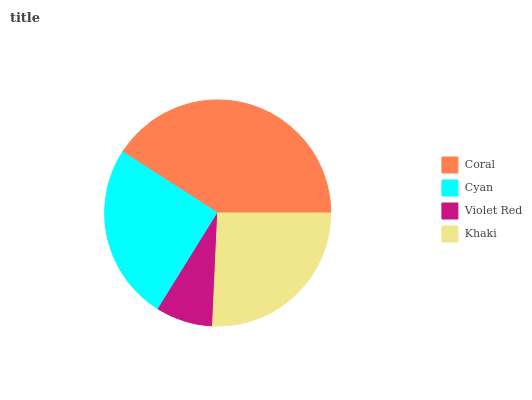Is Violet Red the minimum?
Answer yes or no. Yes. Is Coral the maximum?
Answer yes or no. Yes. Is Cyan the minimum?
Answer yes or no. No. Is Cyan the maximum?
Answer yes or no. No. Is Coral greater than Cyan?
Answer yes or no. Yes. Is Cyan less than Coral?
Answer yes or no. Yes. Is Cyan greater than Coral?
Answer yes or no. No. Is Coral less than Cyan?
Answer yes or no. No. Is Khaki the high median?
Answer yes or no. Yes. Is Cyan the low median?
Answer yes or no. Yes. Is Violet Red the high median?
Answer yes or no. No. Is Violet Red the low median?
Answer yes or no. No. 